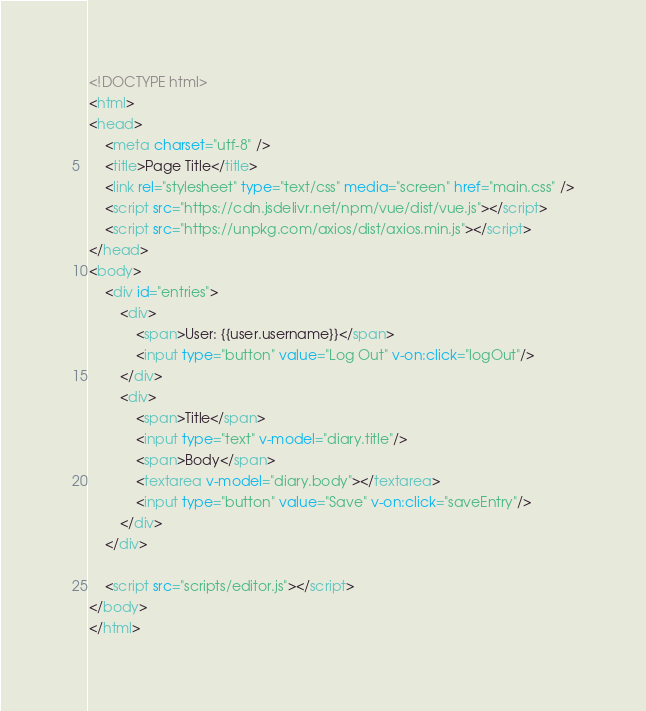Convert code to text. <code><loc_0><loc_0><loc_500><loc_500><_HTML_><!DOCTYPE html>
<html>
<head>
    <meta charset="utf-8" />
    <title>Page Title</title>
    <link rel="stylesheet" type="text/css" media="screen" href="main.css" />
    <script src="https://cdn.jsdelivr.net/npm/vue/dist/vue.js"></script>
    <script src="https://unpkg.com/axios/dist/axios.min.js"></script>
</head>
<body>
    <div id="entries">
        <div>
            <span>User: {{user.username}}</span>
            <input type="button" value="Log Out" v-on:click="logOut"/>
        </div>
        <div>
            <span>Title</span>
            <input type="text" v-model="diary.title"/>
            <span>Body</span>
            <textarea v-model="diary.body"></textarea>
            <input type="button" value="Save" v-on:click="saveEntry"/>
        </div>
    </div>

    <script src="scripts/editor.js"></script>
</body>
</html></code> 